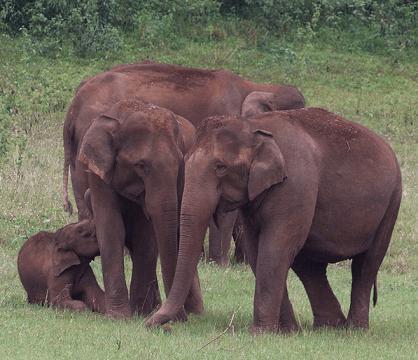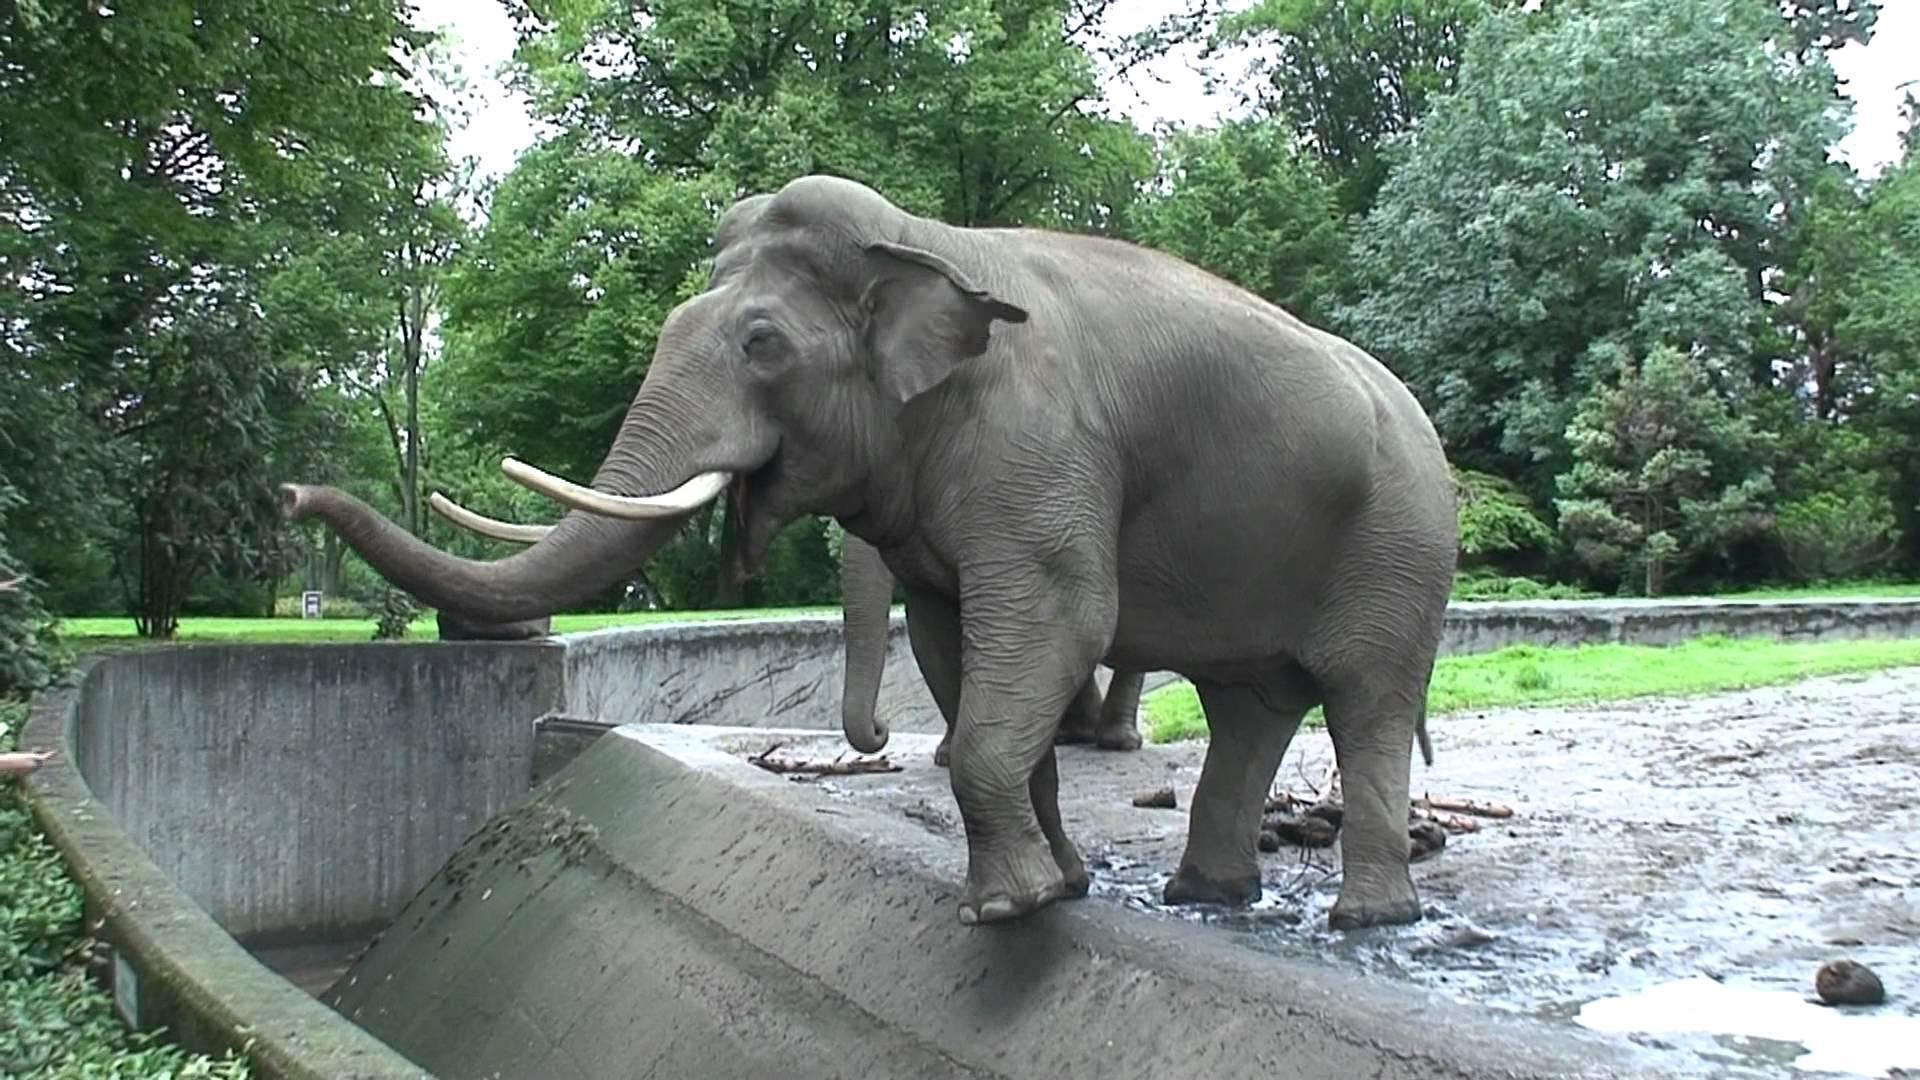The first image is the image on the left, the second image is the image on the right. Evaluate the accuracy of this statement regarding the images: "One of the elephants is near an area of water.". Is it true? Answer yes or no. Yes. The first image is the image on the left, the second image is the image on the right. Analyze the images presented: Is the assertion "Only one image includes an elephant with prominent tusks." valid? Answer yes or no. Yes. 